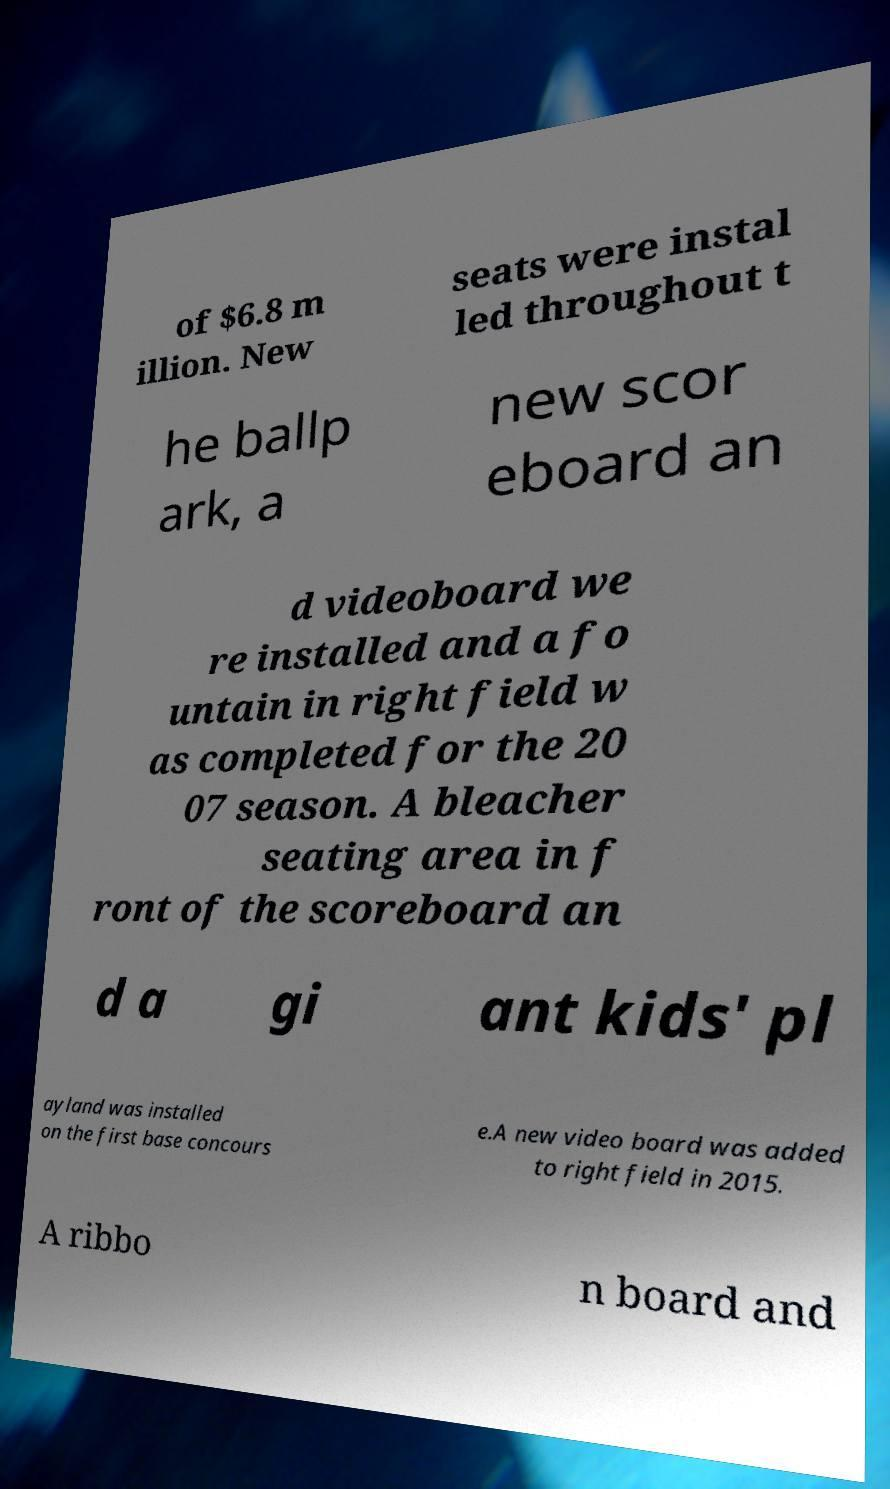For documentation purposes, I need the text within this image transcribed. Could you provide that? of $6.8 m illion. New seats were instal led throughout t he ballp ark, a new scor eboard an d videoboard we re installed and a fo untain in right field w as completed for the 20 07 season. A bleacher seating area in f ront of the scoreboard an d a gi ant kids' pl ayland was installed on the first base concours e.A new video board was added to right field in 2015. A ribbo n board and 